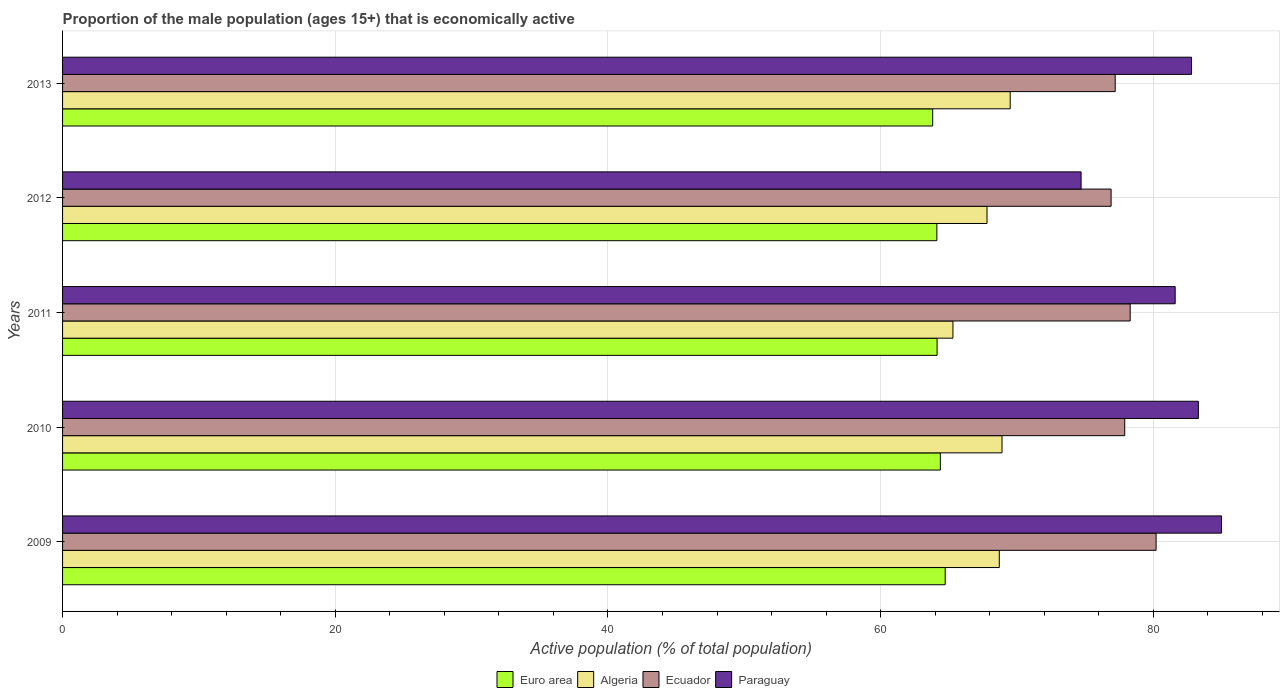How many different coloured bars are there?
Make the answer very short. 4. Are the number of bars per tick equal to the number of legend labels?
Ensure brevity in your answer.  Yes. Are the number of bars on each tick of the Y-axis equal?
Provide a short and direct response. Yes. In how many cases, is the number of bars for a given year not equal to the number of legend labels?
Your answer should be very brief. 0. What is the proportion of the male population that is economically active in Ecuador in 2013?
Give a very brief answer. 77.2. Across all years, what is the maximum proportion of the male population that is economically active in Euro area?
Keep it short and to the point. 64.73. Across all years, what is the minimum proportion of the male population that is economically active in Ecuador?
Your answer should be very brief. 76.9. In which year was the proportion of the male population that is economically active in Ecuador maximum?
Ensure brevity in your answer.  2009. What is the total proportion of the male population that is economically active in Ecuador in the graph?
Provide a succinct answer. 390.5. What is the difference between the proportion of the male population that is economically active in Ecuador in 2009 and that in 2011?
Make the answer very short. 1.9. What is the difference between the proportion of the male population that is economically active in Euro area in 2013 and the proportion of the male population that is economically active in Ecuador in 2012?
Provide a short and direct response. -13.08. What is the average proportion of the male population that is economically active in Ecuador per year?
Your answer should be very brief. 78.1. In the year 2011, what is the difference between the proportion of the male population that is economically active in Paraguay and proportion of the male population that is economically active in Euro area?
Your answer should be very brief. 17.46. What is the ratio of the proportion of the male population that is economically active in Euro area in 2010 to that in 2012?
Offer a terse response. 1. Is the proportion of the male population that is economically active in Ecuador in 2011 less than that in 2012?
Make the answer very short. No. Is the difference between the proportion of the male population that is economically active in Paraguay in 2009 and 2013 greater than the difference between the proportion of the male population that is economically active in Euro area in 2009 and 2013?
Provide a succinct answer. Yes. What is the difference between the highest and the second highest proportion of the male population that is economically active in Euro area?
Provide a short and direct response. 0.36. What is the difference between the highest and the lowest proportion of the male population that is economically active in Algeria?
Keep it short and to the point. 4.2. Is the sum of the proportion of the male population that is economically active in Paraguay in 2009 and 2013 greater than the maximum proportion of the male population that is economically active in Ecuador across all years?
Keep it short and to the point. Yes. What does the 1st bar from the top in 2012 represents?
Ensure brevity in your answer.  Paraguay. What does the 4th bar from the bottom in 2010 represents?
Give a very brief answer. Paraguay. Is it the case that in every year, the sum of the proportion of the male population that is economically active in Euro area and proportion of the male population that is economically active in Algeria is greater than the proportion of the male population that is economically active in Paraguay?
Your response must be concise. Yes. How many bars are there?
Provide a succinct answer. 20. Are all the bars in the graph horizontal?
Offer a very short reply. Yes. Are the values on the major ticks of X-axis written in scientific E-notation?
Provide a succinct answer. No. Does the graph contain any zero values?
Keep it short and to the point. No. Does the graph contain grids?
Your response must be concise. Yes. Where does the legend appear in the graph?
Your answer should be very brief. Bottom center. What is the title of the graph?
Make the answer very short. Proportion of the male population (ages 15+) that is economically active. What is the label or title of the X-axis?
Offer a terse response. Active population (% of total population). What is the label or title of the Y-axis?
Your answer should be very brief. Years. What is the Active population (% of total population) of Euro area in 2009?
Make the answer very short. 64.73. What is the Active population (% of total population) of Algeria in 2009?
Offer a very short reply. 68.7. What is the Active population (% of total population) in Ecuador in 2009?
Make the answer very short. 80.2. What is the Active population (% of total population) in Paraguay in 2009?
Give a very brief answer. 85. What is the Active population (% of total population) of Euro area in 2010?
Make the answer very short. 64.38. What is the Active population (% of total population) in Algeria in 2010?
Provide a short and direct response. 68.9. What is the Active population (% of total population) of Ecuador in 2010?
Ensure brevity in your answer.  77.9. What is the Active population (% of total population) in Paraguay in 2010?
Keep it short and to the point. 83.3. What is the Active population (% of total population) in Euro area in 2011?
Provide a short and direct response. 64.14. What is the Active population (% of total population) in Algeria in 2011?
Your answer should be very brief. 65.3. What is the Active population (% of total population) of Ecuador in 2011?
Provide a short and direct response. 78.3. What is the Active population (% of total population) of Paraguay in 2011?
Offer a very short reply. 81.6. What is the Active population (% of total population) of Euro area in 2012?
Make the answer very short. 64.12. What is the Active population (% of total population) in Algeria in 2012?
Offer a terse response. 67.8. What is the Active population (% of total population) in Ecuador in 2012?
Offer a terse response. 76.9. What is the Active population (% of total population) in Paraguay in 2012?
Make the answer very short. 74.7. What is the Active population (% of total population) in Euro area in 2013?
Make the answer very short. 63.82. What is the Active population (% of total population) in Algeria in 2013?
Your answer should be compact. 69.5. What is the Active population (% of total population) of Ecuador in 2013?
Provide a short and direct response. 77.2. What is the Active population (% of total population) of Paraguay in 2013?
Provide a succinct answer. 82.8. Across all years, what is the maximum Active population (% of total population) in Euro area?
Your response must be concise. 64.73. Across all years, what is the maximum Active population (% of total population) of Algeria?
Make the answer very short. 69.5. Across all years, what is the maximum Active population (% of total population) of Ecuador?
Make the answer very short. 80.2. Across all years, what is the maximum Active population (% of total population) in Paraguay?
Give a very brief answer. 85. Across all years, what is the minimum Active population (% of total population) in Euro area?
Make the answer very short. 63.82. Across all years, what is the minimum Active population (% of total population) of Algeria?
Your answer should be compact. 65.3. Across all years, what is the minimum Active population (% of total population) of Ecuador?
Your answer should be compact. 76.9. Across all years, what is the minimum Active population (% of total population) of Paraguay?
Your answer should be compact. 74.7. What is the total Active population (% of total population) of Euro area in the graph?
Keep it short and to the point. 321.18. What is the total Active population (% of total population) in Algeria in the graph?
Your answer should be compact. 340.2. What is the total Active population (% of total population) of Ecuador in the graph?
Your response must be concise. 390.5. What is the total Active population (% of total population) in Paraguay in the graph?
Provide a succinct answer. 407.4. What is the difference between the Active population (% of total population) in Euro area in 2009 and that in 2010?
Offer a terse response. 0.35. What is the difference between the Active population (% of total population) in Algeria in 2009 and that in 2010?
Provide a succinct answer. -0.2. What is the difference between the Active population (% of total population) in Euro area in 2009 and that in 2011?
Keep it short and to the point. 0.6. What is the difference between the Active population (% of total population) in Euro area in 2009 and that in 2012?
Make the answer very short. 0.61. What is the difference between the Active population (% of total population) of Algeria in 2009 and that in 2012?
Your answer should be compact. 0.9. What is the difference between the Active population (% of total population) in Ecuador in 2009 and that in 2012?
Provide a succinct answer. 3.3. What is the difference between the Active population (% of total population) in Euro area in 2009 and that in 2013?
Your answer should be compact. 0.92. What is the difference between the Active population (% of total population) of Algeria in 2009 and that in 2013?
Ensure brevity in your answer.  -0.8. What is the difference between the Active population (% of total population) in Ecuador in 2009 and that in 2013?
Ensure brevity in your answer.  3. What is the difference between the Active population (% of total population) of Paraguay in 2009 and that in 2013?
Provide a short and direct response. 2.2. What is the difference between the Active population (% of total population) in Euro area in 2010 and that in 2011?
Your answer should be very brief. 0.24. What is the difference between the Active population (% of total population) in Paraguay in 2010 and that in 2011?
Ensure brevity in your answer.  1.7. What is the difference between the Active population (% of total population) in Euro area in 2010 and that in 2012?
Give a very brief answer. 0.26. What is the difference between the Active population (% of total population) of Ecuador in 2010 and that in 2012?
Provide a succinct answer. 1. What is the difference between the Active population (% of total population) of Paraguay in 2010 and that in 2012?
Your answer should be very brief. 8.6. What is the difference between the Active population (% of total population) of Euro area in 2010 and that in 2013?
Your answer should be compact. 0.56. What is the difference between the Active population (% of total population) in Euro area in 2011 and that in 2012?
Keep it short and to the point. 0.02. What is the difference between the Active population (% of total population) of Algeria in 2011 and that in 2012?
Your answer should be compact. -2.5. What is the difference between the Active population (% of total population) of Paraguay in 2011 and that in 2012?
Your response must be concise. 6.9. What is the difference between the Active population (% of total population) in Euro area in 2011 and that in 2013?
Make the answer very short. 0.32. What is the difference between the Active population (% of total population) of Algeria in 2011 and that in 2013?
Your response must be concise. -4.2. What is the difference between the Active population (% of total population) of Euro area in 2012 and that in 2013?
Give a very brief answer. 0.3. What is the difference between the Active population (% of total population) of Ecuador in 2012 and that in 2013?
Your answer should be compact. -0.3. What is the difference between the Active population (% of total population) in Euro area in 2009 and the Active population (% of total population) in Algeria in 2010?
Make the answer very short. -4.17. What is the difference between the Active population (% of total population) of Euro area in 2009 and the Active population (% of total population) of Ecuador in 2010?
Your answer should be compact. -13.17. What is the difference between the Active population (% of total population) of Euro area in 2009 and the Active population (% of total population) of Paraguay in 2010?
Your answer should be very brief. -18.57. What is the difference between the Active population (% of total population) of Algeria in 2009 and the Active population (% of total population) of Ecuador in 2010?
Provide a short and direct response. -9.2. What is the difference between the Active population (% of total population) in Algeria in 2009 and the Active population (% of total population) in Paraguay in 2010?
Your answer should be compact. -14.6. What is the difference between the Active population (% of total population) of Ecuador in 2009 and the Active population (% of total population) of Paraguay in 2010?
Your answer should be compact. -3.1. What is the difference between the Active population (% of total population) in Euro area in 2009 and the Active population (% of total population) in Algeria in 2011?
Provide a succinct answer. -0.57. What is the difference between the Active population (% of total population) in Euro area in 2009 and the Active population (% of total population) in Ecuador in 2011?
Your response must be concise. -13.57. What is the difference between the Active population (% of total population) in Euro area in 2009 and the Active population (% of total population) in Paraguay in 2011?
Keep it short and to the point. -16.87. What is the difference between the Active population (% of total population) of Algeria in 2009 and the Active population (% of total population) of Ecuador in 2011?
Provide a succinct answer. -9.6. What is the difference between the Active population (% of total population) in Algeria in 2009 and the Active population (% of total population) in Paraguay in 2011?
Your response must be concise. -12.9. What is the difference between the Active population (% of total population) in Euro area in 2009 and the Active population (% of total population) in Algeria in 2012?
Keep it short and to the point. -3.07. What is the difference between the Active population (% of total population) of Euro area in 2009 and the Active population (% of total population) of Ecuador in 2012?
Your response must be concise. -12.17. What is the difference between the Active population (% of total population) of Euro area in 2009 and the Active population (% of total population) of Paraguay in 2012?
Your response must be concise. -9.97. What is the difference between the Active population (% of total population) in Algeria in 2009 and the Active population (% of total population) in Paraguay in 2012?
Keep it short and to the point. -6. What is the difference between the Active population (% of total population) of Ecuador in 2009 and the Active population (% of total population) of Paraguay in 2012?
Your answer should be compact. 5.5. What is the difference between the Active population (% of total population) of Euro area in 2009 and the Active population (% of total population) of Algeria in 2013?
Make the answer very short. -4.77. What is the difference between the Active population (% of total population) of Euro area in 2009 and the Active population (% of total population) of Ecuador in 2013?
Ensure brevity in your answer.  -12.47. What is the difference between the Active population (% of total population) in Euro area in 2009 and the Active population (% of total population) in Paraguay in 2013?
Your answer should be compact. -18.07. What is the difference between the Active population (% of total population) in Algeria in 2009 and the Active population (% of total population) in Paraguay in 2013?
Provide a succinct answer. -14.1. What is the difference between the Active population (% of total population) in Euro area in 2010 and the Active population (% of total population) in Algeria in 2011?
Give a very brief answer. -0.92. What is the difference between the Active population (% of total population) in Euro area in 2010 and the Active population (% of total population) in Ecuador in 2011?
Offer a terse response. -13.92. What is the difference between the Active population (% of total population) in Euro area in 2010 and the Active population (% of total population) in Paraguay in 2011?
Provide a short and direct response. -17.22. What is the difference between the Active population (% of total population) of Algeria in 2010 and the Active population (% of total population) of Ecuador in 2011?
Offer a terse response. -9.4. What is the difference between the Active population (% of total population) in Euro area in 2010 and the Active population (% of total population) in Algeria in 2012?
Ensure brevity in your answer.  -3.42. What is the difference between the Active population (% of total population) in Euro area in 2010 and the Active population (% of total population) in Ecuador in 2012?
Provide a short and direct response. -12.52. What is the difference between the Active population (% of total population) in Euro area in 2010 and the Active population (% of total population) in Paraguay in 2012?
Your response must be concise. -10.32. What is the difference between the Active population (% of total population) of Algeria in 2010 and the Active population (% of total population) of Paraguay in 2012?
Keep it short and to the point. -5.8. What is the difference between the Active population (% of total population) of Ecuador in 2010 and the Active population (% of total population) of Paraguay in 2012?
Give a very brief answer. 3.2. What is the difference between the Active population (% of total population) in Euro area in 2010 and the Active population (% of total population) in Algeria in 2013?
Provide a short and direct response. -5.12. What is the difference between the Active population (% of total population) of Euro area in 2010 and the Active population (% of total population) of Ecuador in 2013?
Provide a succinct answer. -12.82. What is the difference between the Active population (% of total population) of Euro area in 2010 and the Active population (% of total population) of Paraguay in 2013?
Your response must be concise. -18.42. What is the difference between the Active population (% of total population) in Algeria in 2010 and the Active population (% of total population) in Ecuador in 2013?
Offer a terse response. -8.3. What is the difference between the Active population (% of total population) of Ecuador in 2010 and the Active population (% of total population) of Paraguay in 2013?
Offer a very short reply. -4.9. What is the difference between the Active population (% of total population) in Euro area in 2011 and the Active population (% of total population) in Algeria in 2012?
Offer a very short reply. -3.66. What is the difference between the Active population (% of total population) of Euro area in 2011 and the Active population (% of total population) of Ecuador in 2012?
Offer a terse response. -12.76. What is the difference between the Active population (% of total population) in Euro area in 2011 and the Active population (% of total population) in Paraguay in 2012?
Make the answer very short. -10.56. What is the difference between the Active population (% of total population) of Algeria in 2011 and the Active population (% of total population) of Ecuador in 2012?
Keep it short and to the point. -11.6. What is the difference between the Active population (% of total population) in Euro area in 2011 and the Active population (% of total population) in Algeria in 2013?
Give a very brief answer. -5.36. What is the difference between the Active population (% of total population) in Euro area in 2011 and the Active population (% of total population) in Ecuador in 2013?
Your answer should be compact. -13.06. What is the difference between the Active population (% of total population) in Euro area in 2011 and the Active population (% of total population) in Paraguay in 2013?
Provide a succinct answer. -18.66. What is the difference between the Active population (% of total population) in Algeria in 2011 and the Active population (% of total population) in Ecuador in 2013?
Your answer should be compact. -11.9. What is the difference between the Active population (% of total population) in Algeria in 2011 and the Active population (% of total population) in Paraguay in 2013?
Provide a succinct answer. -17.5. What is the difference between the Active population (% of total population) of Ecuador in 2011 and the Active population (% of total population) of Paraguay in 2013?
Offer a very short reply. -4.5. What is the difference between the Active population (% of total population) of Euro area in 2012 and the Active population (% of total population) of Algeria in 2013?
Give a very brief answer. -5.38. What is the difference between the Active population (% of total population) in Euro area in 2012 and the Active population (% of total population) in Ecuador in 2013?
Your response must be concise. -13.08. What is the difference between the Active population (% of total population) of Euro area in 2012 and the Active population (% of total population) of Paraguay in 2013?
Make the answer very short. -18.68. What is the difference between the Active population (% of total population) of Algeria in 2012 and the Active population (% of total population) of Ecuador in 2013?
Your response must be concise. -9.4. What is the difference between the Active population (% of total population) in Algeria in 2012 and the Active population (% of total population) in Paraguay in 2013?
Your answer should be compact. -15. What is the difference between the Active population (% of total population) of Ecuador in 2012 and the Active population (% of total population) of Paraguay in 2013?
Provide a short and direct response. -5.9. What is the average Active population (% of total population) of Euro area per year?
Provide a succinct answer. 64.24. What is the average Active population (% of total population) in Algeria per year?
Ensure brevity in your answer.  68.04. What is the average Active population (% of total population) of Ecuador per year?
Ensure brevity in your answer.  78.1. What is the average Active population (% of total population) of Paraguay per year?
Ensure brevity in your answer.  81.48. In the year 2009, what is the difference between the Active population (% of total population) of Euro area and Active population (% of total population) of Algeria?
Offer a very short reply. -3.97. In the year 2009, what is the difference between the Active population (% of total population) in Euro area and Active population (% of total population) in Ecuador?
Offer a terse response. -15.47. In the year 2009, what is the difference between the Active population (% of total population) in Euro area and Active population (% of total population) in Paraguay?
Provide a short and direct response. -20.27. In the year 2009, what is the difference between the Active population (% of total population) in Algeria and Active population (% of total population) in Paraguay?
Provide a short and direct response. -16.3. In the year 2010, what is the difference between the Active population (% of total population) in Euro area and Active population (% of total population) in Algeria?
Provide a succinct answer. -4.52. In the year 2010, what is the difference between the Active population (% of total population) of Euro area and Active population (% of total population) of Ecuador?
Your answer should be very brief. -13.52. In the year 2010, what is the difference between the Active population (% of total population) in Euro area and Active population (% of total population) in Paraguay?
Keep it short and to the point. -18.92. In the year 2010, what is the difference between the Active population (% of total population) of Algeria and Active population (% of total population) of Ecuador?
Your answer should be very brief. -9. In the year 2010, what is the difference between the Active population (% of total population) of Algeria and Active population (% of total population) of Paraguay?
Ensure brevity in your answer.  -14.4. In the year 2011, what is the difference between the Active population (% of total population) of Euro area and Active population (% of total population) of Algeria?
Your response must be concise. -1.16. In the year 2011, what is the difference between the Active population (% of total population) in Euro area and Active population (% of total population) in Ecuador?
Offer a terse response. -14.16. In the year 2011, what is the difference between the Active population (% of total population) of Euro area and Active population (% of total population) of Paraguay?
Your answer should be compact. -17.46. In the year 2011, what is the difference between the Active population (% of total population) in Algeria and Active population (% of total population) in Paraguay?
Your answer should be compact. -16.3. In the year 2011, what is the difference between the Active population (% of total population) in Ecuador and Active population (% of total population) in Paraguay?
Offer a terse response. -3.3. In the year 2012, what is the difference between the Active population (% of total population) in Euro area and Active population (% of total population) in Algeria?
Ensure brevity in your answer.  -3.68. In the year 2012, what is the difference between the Active population (% of total population) of Euro area and Active population (% of total population) of Ecuador?
Your answer should be very brief. -12.78. In the year 2012, what is the difference between the Active population (% of total population) of Euro area and Active population (% of total population) of Paraguay?
Your answer should be very brief. -10.58. In the year 2013, what is the difference between the Active population (% of total population) in Euro area and Active population (% of total population) in Algeria?
Provide a succinct answer. -5.68. In the year 2013, what is the difference between the Active population (% of total population) in Euro area and Active population (% of total population) in Ecuador?
Your answer should be very brief. -13.38. In the year 2013, what is the difference between the Active population (% of total population) in Euro area and Active population (% of total population) in Paraguay?
Offer a terse response. -18.98. In the year 2013, what is the difference between the Active population (% of total population) of Ecuador and Active population (% of total population) of Paraguay?
Your response must be concise. -5.6. What is the ratio of the Active population (% of total population) of Euro area in 2009 to that in 2010?
Provide a succinct answer. 1.01. What is the ratio of the Active population (% of total population) of Ecuador in 2009 to that in 2010?
Ensure brevity in your answer.  1.03. What is the ratio of the Active population (% of total population) in Paraguay in 2009 to that in 2010?
Offer a terse response. 1.02. What is the ratio of the Active population (% of total population) in Euro area in 2009 to that in 2011?
Your answer should be compact. 1.01. What is the ratio of the Active population (% of total population) in Algeria in 2009 to that in 2011?
Give a very brief answer. 1.05. What is the ratio of the Active population (% of total population) in Ecuador in 2009 to that in 2011?
Offer a terse response. 1.02. What is the ratio of the Active population (% of total population) in Paraguay in 2009 to that in 2011?
Provide a succinct answer. 1.04. What is the ratio of the Active population (% of total population) of Euro area in 2009 to that in 2012?
Your answer should be compact. 1.01. What is the ratio of the Active population (% of total population) of Algeria in 2009 to that in 2012?
Give a very brief answer. 1.01. What is the ratio of the Active population (% of total population) in Ecuador in 2009 to that in 2012?
Offer a very short reply. 1.04. What is the ratio of the Active population (% of total population) of Paraguay in 2009 to that in 2012?
Ensure brevity in your answer.  1.14. What is the ratio of the Active population (% of total population) of Euro area in 2009 to that in 2013?
Provide a short and direct response. 1.01. What is the ratio of the Active population (% of total population) of Algeria in 2009 to that in 2013?
Ensure brevity in your answer.  0.99. What is the ratio of the Active population (% of total population) in Ecuador in 2009 to that in 2013?
Keep it short and to the point. 1.04. What is the ratio of the Active population (% of total population) in Paraguay in 2009 to that in 2013?
Your response must be concise. 1.03. What is the ratio of the Active population (% of total population) of Euro area in 2010 to that in 2011?
Make the answer very short. 1. What is the ratio of the Active population (% of total population) of Algeria in 2010 to that in 2011?
Offer a very short reply. 1.06. What is the ratio of the Active population (% of total population) in Ecuador in 2010 to that in 2011?
Provide a short and direct response. 0.99. What is the ratio of the Active population (% of total population) of Paraguay in 2010 to that in 2011?
Ensure brevity in your answer.  1.02. What is the ratio of the Active population (% of total population) of Algeria in 2010 to that in 2012?
Offer a very short reply. 1.02. What is the ratio of the Active population (% of total population) in Ecuador in 2010 to that in 2012?
Your answer should be compact. 1.01. What is the ratio of the Active population (% of total population) in Paraguay in 2010 to that in 2012?
Your response must be concise. 1.12. What is the ratio of the Active population (% of total population) in Euro area in 2010 to that in 2013?
Your answer should be compact. 1.01. What is the ratio of the Active population (% of total population) of Algeria in 2010 to that in 2013?
Your response must be concise. 0.99. What is the ratio of the Active population (% of total population) of Ecuador in 2010 to that in 2013?
Offer a terse response. 1.01. What is the ratio of the Active population (% of total population) in Euro area in 2011 to that in 2012?
Your answer should be very brief. 1. What is the ratio of the Active population (% of total population) of Algeria in 2011 to that in 2012?
Offer a terse response. 0.96. What is the ratio of the Active population (% of total population) of Ecuador in 2011 to that in 2012?
Keep it short and to the point. 1.02. What is the ratio of the Active population (% of total population) of Paraguay in 2011 to that in 2012?
Provide a succinct answer. 1.09. What is the ratio of the Active population (% of total population) of Algeria in 2011 to that in 2013?
Provide a short and direct response. 0.94. What is the ratio of the Active population (% of total population) in Ecuador in 2011 to that in 2013?
Provide a short and direct response. 1.01. What is the ratio of the Active population (% of total population) in Paraguay in 2011 to that in 2013?
Give a very brief answer. 0.99. What is the ratio of the Active population (% of total population) of Euro area in 2012 to that in 2013?
Your response must be concise. 1. What is the ratio of the Active population (% of total population) in Algeria in 2012 to that in 2013?
Provide a succinct answer. 0.98. What is the ratio of the Active population (% of total population) in Paraguay in 2012 to that in 2013?
Give a very brief answer. 0.9. What is the difference between the highest and the second highest Active population (% of total population) in Euro area?
Your answer should be compact. 0.35. What is the difference between the highest and the second highest Active population (% of total population) of Algeria?
Your response must be concise. 0.6. What is the difference between the highest and the lowest Active population (% of total population) in Euro area?
Ensure brevity in your answer.  0.92. What is the difference between the highest and the lowest Active population (% of total population) in Algeria?
Your answer should be compact. 4.2. What is the difference between the highest and the lowest Active population (% of total population) of Paraguay?
Make the answer very short. 10.3. 